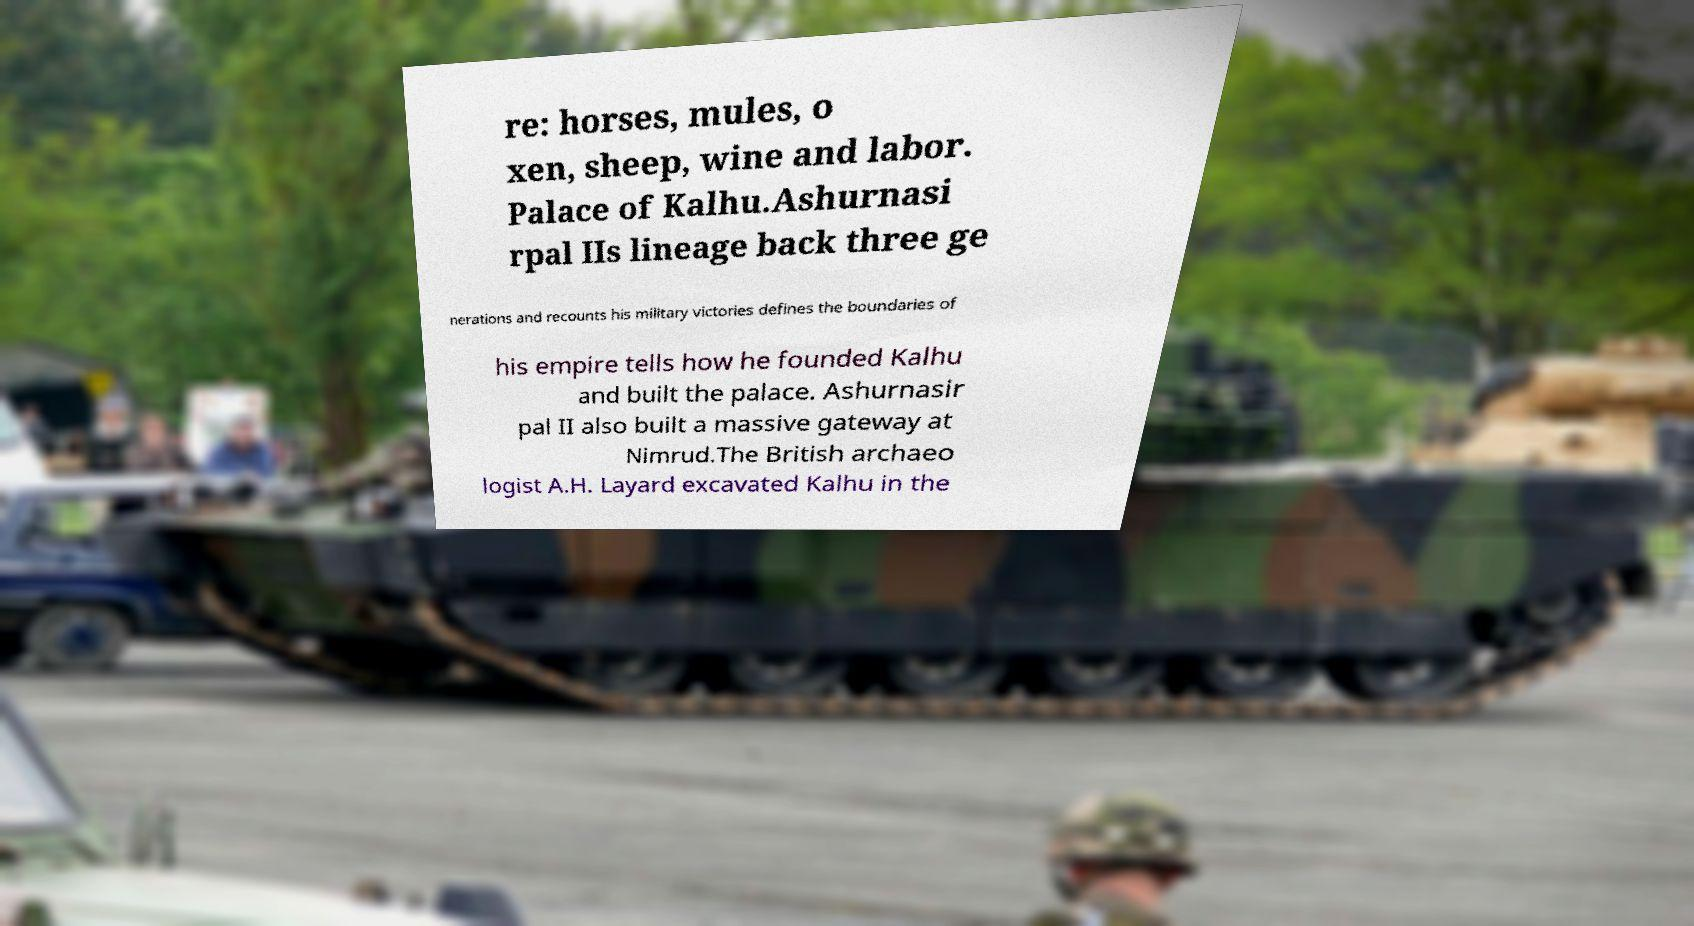What messages or text are displayed in this image? I need them in a readable, typed format. re: horses, mules, o xen, sheep, wine and labor. Palace of Kalhu.Ashurnasi rpal IIs lineage back three ge nerations and recounts his military victories defines the boundaries of his empire tells how he founded Kalhu and built the palace. Ashurnasir pal II also built a massive gateway at Nimrud.The British archaeo logist A.H. Layard excavated Kalhu in the 